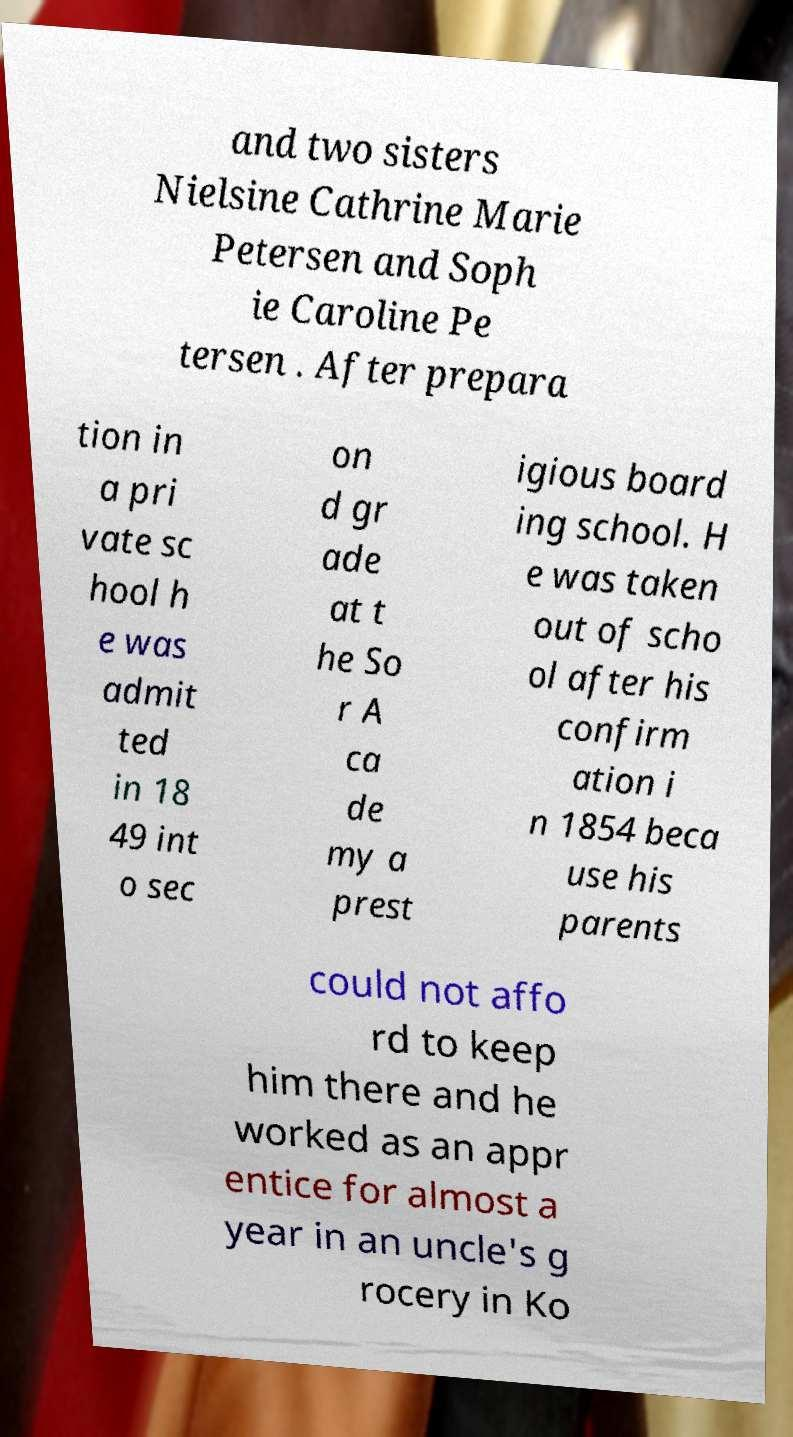Can you read and provide the text displayed in the image?This photo seems to have some interesting text. Can you extract and type it out for me? and two sisters Nielsine Cathrine Marie Petersen and Soph ie Caroline Pe tersen . After prepara tion in a pri vate sc hool h e was admit ted in 18 49 int o sec on d gr ade at t he So r A ca de my a prest igious board ing school. H e was taken out of scho ol after his confirm ation i n 1854 beca use his parents could not affo rd to keep him there and he worked as an appr entice for almost a year in an uncle's g rocery in Ko 